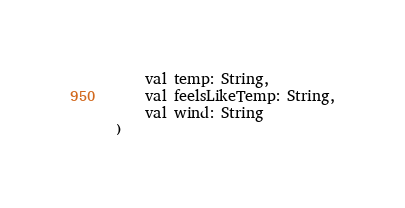Convert code to text. <code><loc_0><loc_0><loc_500><loc_500><_Kotlin_>    val temp: String,
    val feelsLikeTemp: String,
    val wind: String
)</code> 